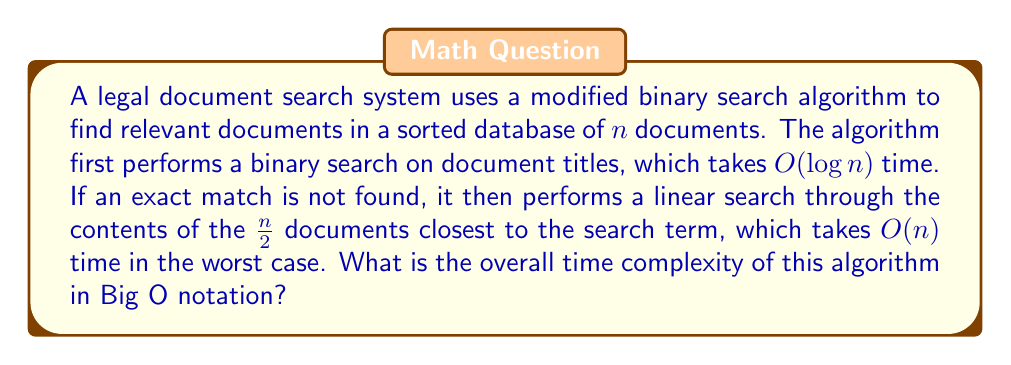Can you answer this question? To determine the overall time complexity, we need to analyze the two main components of the algorithm:

1. Binary search on document titles:
   - This operation has a time complexity of $O(\log n)$

2. Linear search through document contents:
   - In the worst case, this operation searches through $\frac{n}{2}$ documents
   - The time complexity of a linear search is $O(n)$

The total time complexity is the sum of these two components:

$$T(n) = O(\log n) + O(n)$$

In Big O notation, we only consider the dominant term when adding complexities. Since $O(n)$ grows faster than $O(\log n)$ for large values of $n$, it dominates the overall time complexity.

Therefore, the overall time complexity of the algorithm is $O(n)$.

This analysis demonstrates that while the initial binary search is efficient, the subsequent linear search through document contents becomes the bottleneck in terms of time complexity. For a law student interested in the practical application of legal technologies, this insight could be valuable when considering the efficiency of document search systems in large legal databases.
Answer: $O(n)$ 